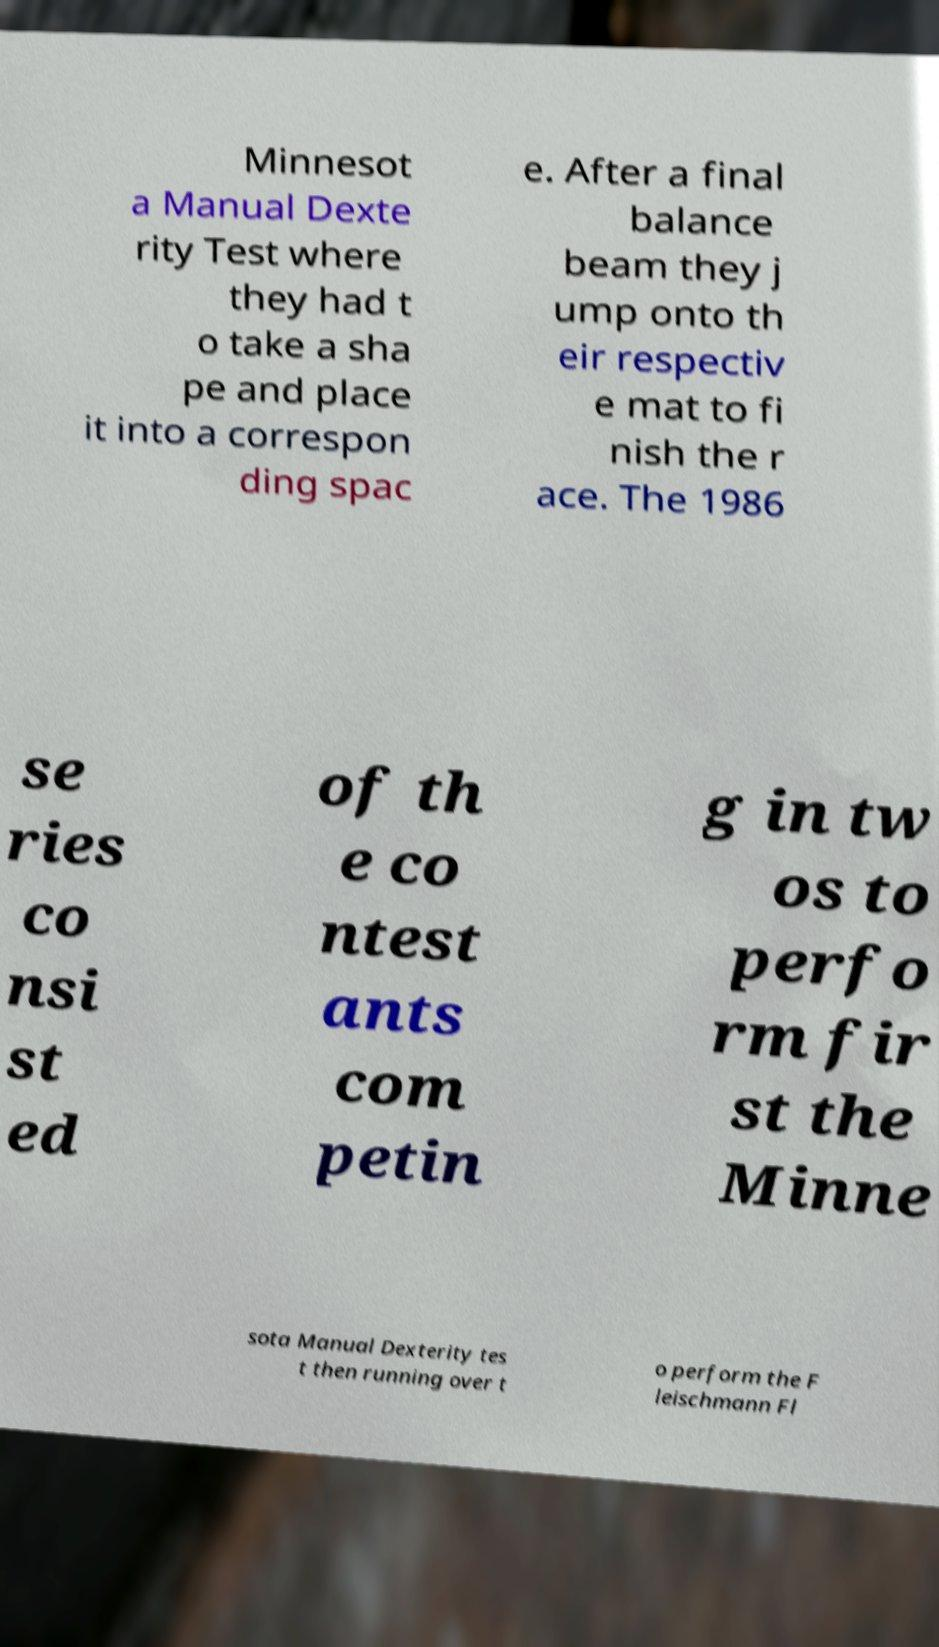Could you extract and type out the text from this image? Minnesot a Manual Dexte rity Test where they had t o take a sha pe and place it into a correspon ding spac e. After a final balance beam they j ump onto th eir respectiv e mat to fi nish the r ace. The 1986 se ries co nsi st ed of th e co ntest ants com petin g in tw os to perfo rm fir st the Minne sota Manual Dexterity tes t then running over t o perform the F leischmann Fl 